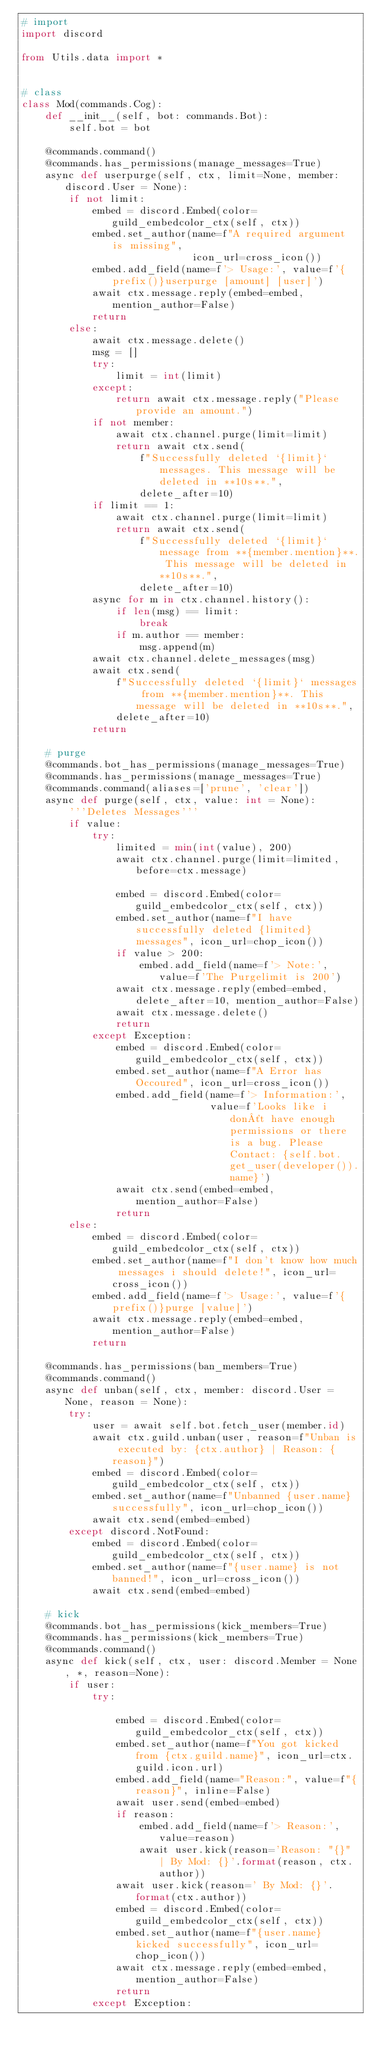Convert code to text. <code><loc_0><loc_0><loc_500><loc_500><_Python_># import
import discord

from Utils.data import *


# class
class Mod(commands.Cog):
    def __init__(self, bot: commands.Bot):
        self.bot = bot

    @commands.command()
    @commands.has_permissions(manage_messages=True)
    async def userpurge(self, ctx, limit=None, member: discord.User = None):
        if not limit:
            embed = discord.Embed(color=guild_embedcolor_ctx(self, ctx))
            embed.set_author(name=f"A required argument is missing",
                             icon_url=cross_icon())
            embed.add_field(name=f'> Usage:', value=f'{prefix()}userpurge [amount] [user]')
            await ctx.message.reply(embed=embed, mention_author=False)
            return
        else:
            await ctx.message.delete()
            msg = []
            try:
                limit = int(limit)
            except:
                return await ctx.message.reply("Please provide an amount.")
            if not member:
                await ctx.channel.purge(limit=limit)
                return await ctx.send(
                    f"Successfully deleted `{limit}` messages. This message will be deleted in **10s**.",
                    delete_after=10)
            if limit == 1:
                await ctx.channel.purge(limit=limit)
                return await ctx.send(
                    f"Successfully deleted `{limit}` message from **{member.mention}**. This message will be deleted in **10s**.",
                    delete_after=10)
            async for m in ctx.channel.history():
                if len(msg) == limit:
                    break
                if m.author == member:
                    msg.append(m)
            await ctx.channel.delete_messages(msg)
            await ctx.send(
                f"Successfully deleted `{limit}` messages from **{member.mention}**. This message will be deleted in **10s**.",
                delete_after=10)
            return

    # purge
    @commands.bot_has_permissions(manage_messages=True)
    @commands.has_permissions(manage_messages=True)
    @commands.command(aliases=['prune', 'clear'])
    async def purge(self, ctx, value: int = None):
        '''Deletes Messages'''
        if value:
            try:
                limited = min(int(value), 200)
                await ctx.channel.purge(limit=limited, before=ctx.message)

                embed = discord.Embed(color=guild_embedcolor_ctx(self, ctx))
                embed.set_author(name=f"I have successfully deleted {limited} messages", icon_url=chop_icon())
                if value > 200:
                    embed.add_field(name=f'> Note:', value=f'The Purgelimit is 200')
                await ctx.message.reply(embed=embed, delete_after=10, mention_author=False)
                await ctx.message.delete()
                return
            except Exception:
                embed = discord.Embed(color=guild_embedcolor_ctx(self, ctx))
                embed.set_author(name=f"A Error has Occoured", icon_url=cross_icon())
                embed.add_field(name=f'> Information:',
                                value=f'Looks like i don´t have enough permissions or there is a bug. Please Contact: {self.bot.get_user(developer()).name}')
                await ctx.send(embed=embed, mention_author=False)
                return
        else:
            embed = discord.Embed(color=guild_embedcolor_ctx(self, ctx))
            embed.set_author(name=f"I don't know how much messages i should delete!", icon_url=cross_icon())
            embed.add_field(name=f'> Usage:', value=f'{prefix()}purge [value]')
            await ctx.message.reply(embed=embed, mention_author=False)
            return

    @commands.has_permissions(ban_members=True)
    @commands.command()
    async def unban(self, ctx, member: discord.User = None, reason = None):
        try:
            user = await self.bot.fetch_user(member.id)
            await ctx.guild.unban(user, reason=f"Unban is executed by: {ctx.author} | Reason: {reason}")
            embed = discord.Embed(color=guild_embedcolor_ctx(self, ctx))
            embed.set_author(name=f"Unbanned {user.name} successfully", icon_url=chop_icon())
            await ctx.send(embed=embed)
        except discord.NotFound:
            embed = discord.Embed(color=guild_embedcolor_ctx(self, ctx))
            embed.set_author(name=f"{user.name} is not banned!", icon_url=cross_icon())
            await ctx.send(embed=embed)

    # kick
    @commands.bot_has_permissions(kick_members=True)
    @commands.has_permissions(kick_members=True)
    @commands.command()
    async def kick(self, ctx, user: discord.Member = None, *, reason=None):
        if user:
            try:

                embed = discord.Embed(color=guild_embedcolor_ctx(self, ctx))
                embed.set_author(name=f"You got kicked from {ctx.guild.name}", icon_url=ctx.guild.icon.url)
                embed.add_field(name="Reason:", value=f"{reason}", inline=False)
                await user.send(embed=embed)
                if reason:
                    embed.add_field(name=f'> Reason:', value=reason)
                    await user.kick(reason='Reason: "{}" | By Mod: {}'.format(reason, ctx.author))
                await user.kick(reason=' By Mod: {}'.format(ctx.author))
                embed = discord.Embed(color=guild_embedcolor_ctx(self, ctx))
                embed.set_author(name=f"{user.name} kicked successfully", icon_url=chop_icon())
                await ctx.message.reply(embed=embed, mention_author=False)
                return
            except Exception:</code> 